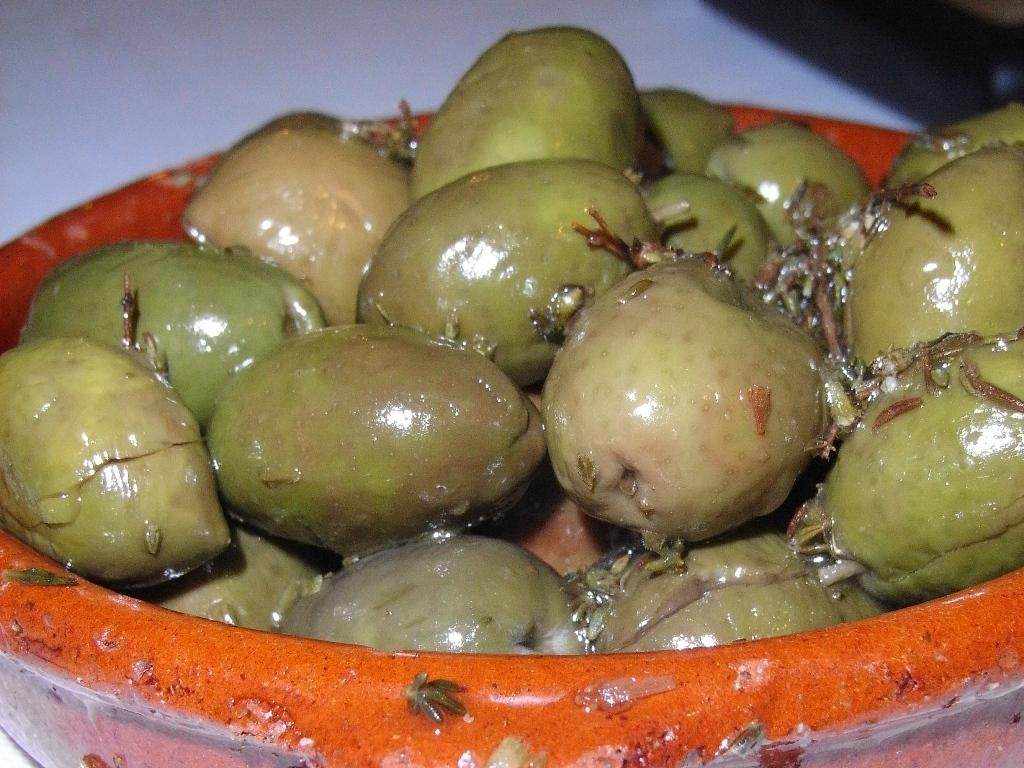What type of food can be seen in the image? There are fruits in the image. How are the fruits arranged in the image? The fruits are placed in a bowl. What type of humor can be seen in the image? There is no humor present in the image; it features fruits in a bowl. Is there a spy observing the fruits in the image? There is no indication of a spy or any surveillance activity in the image. 